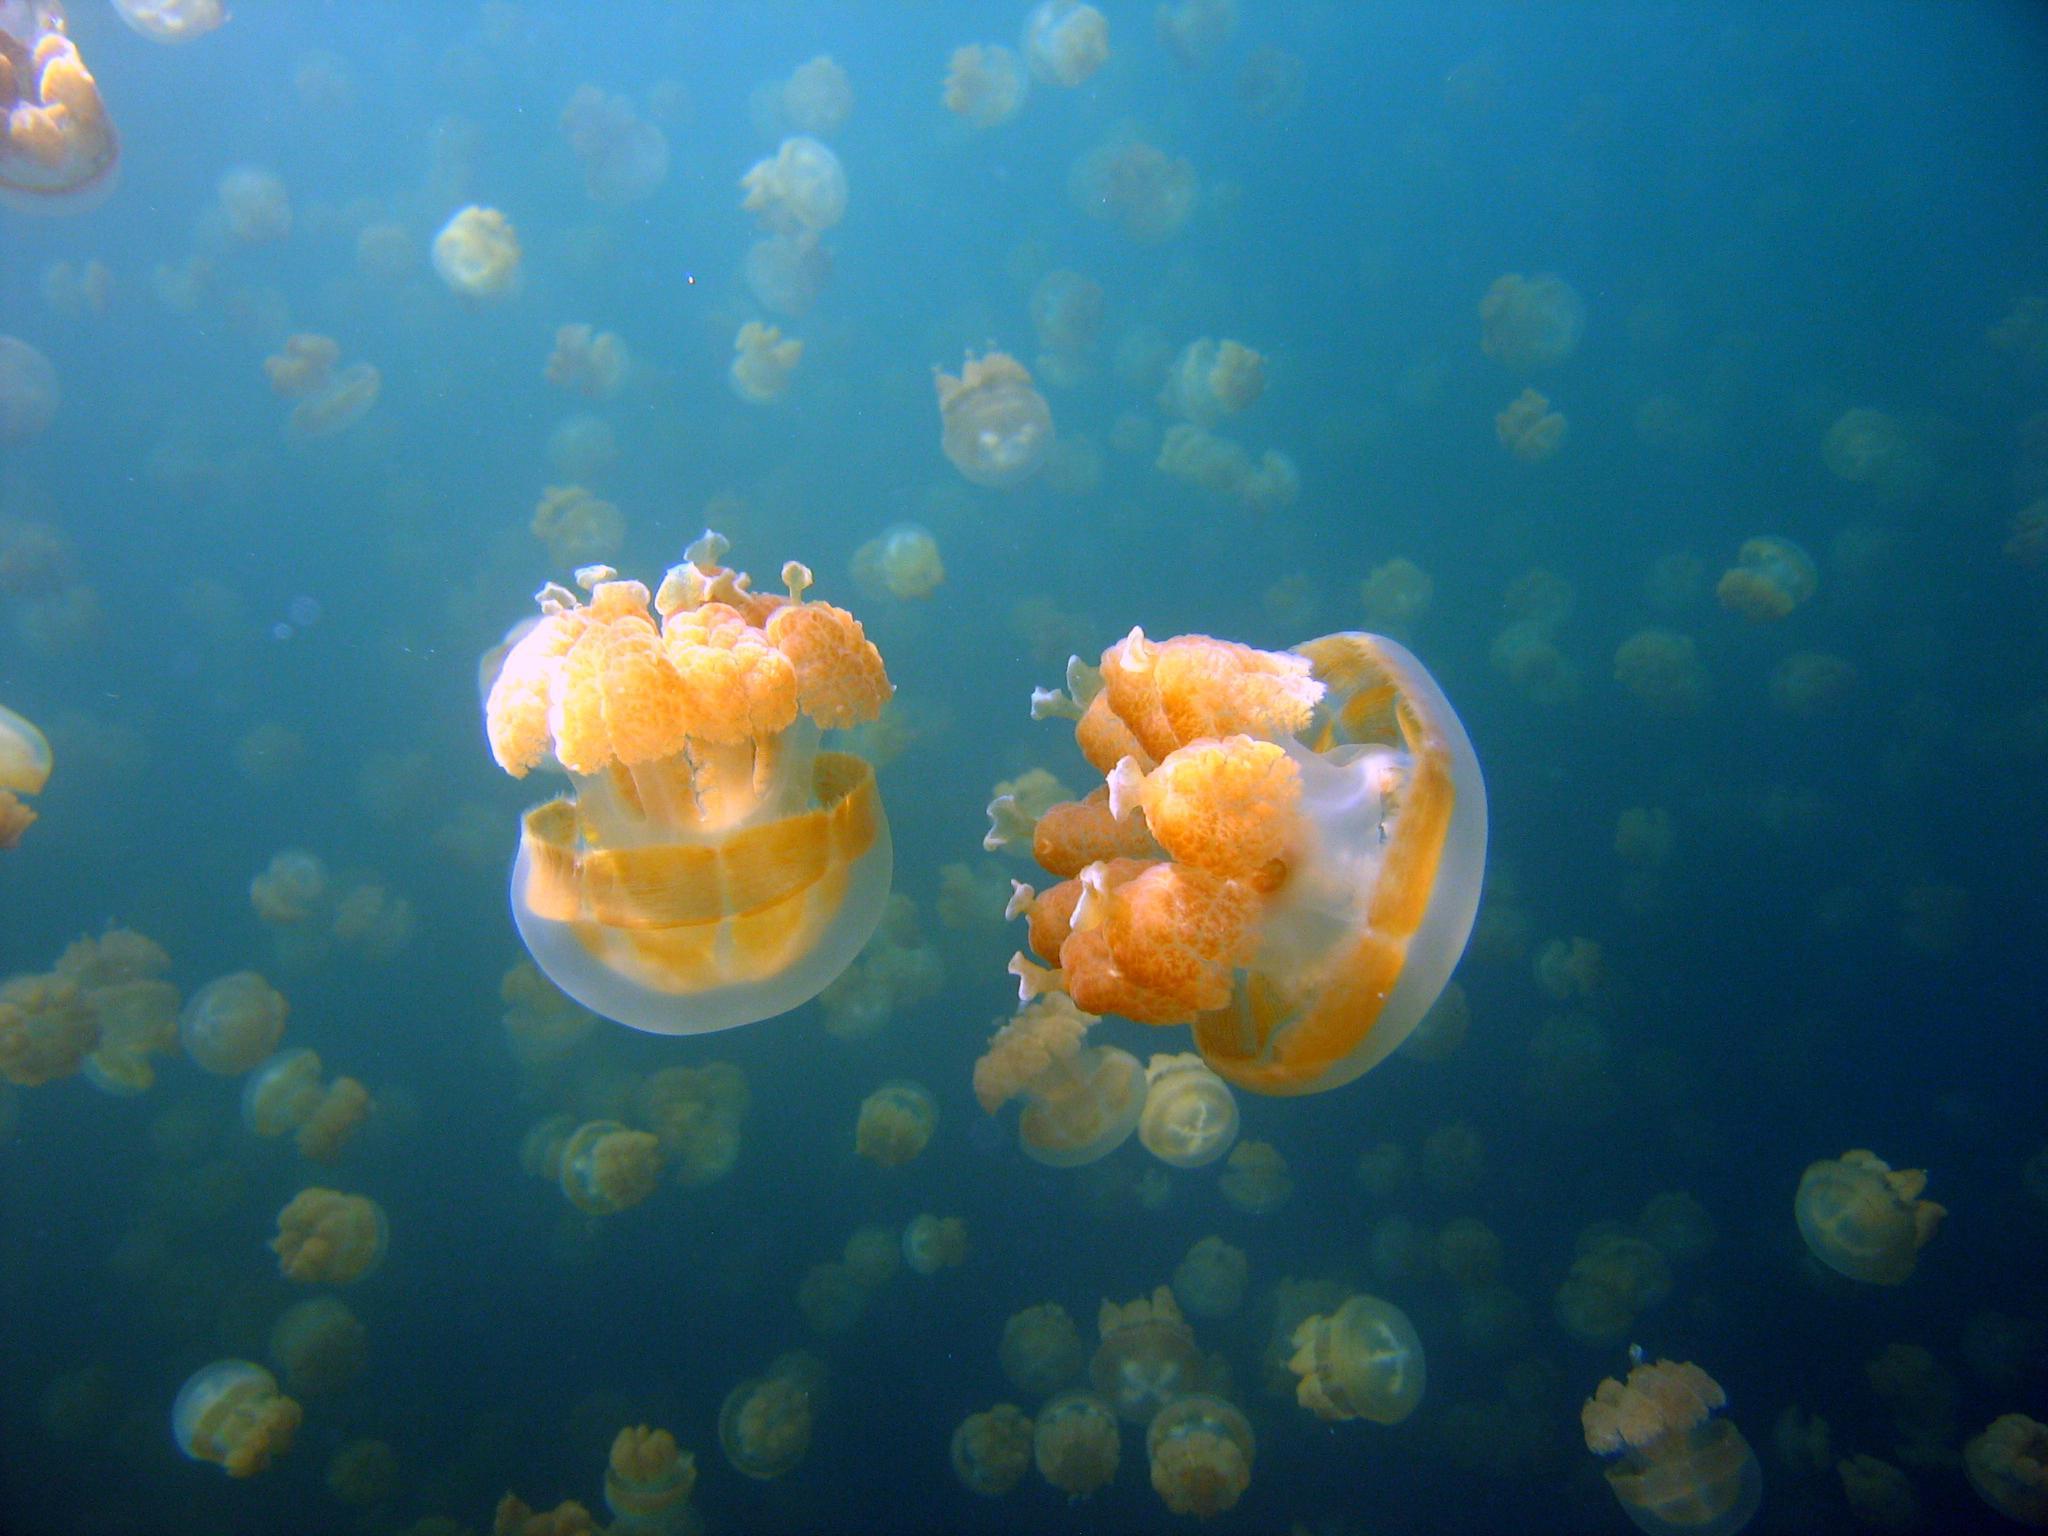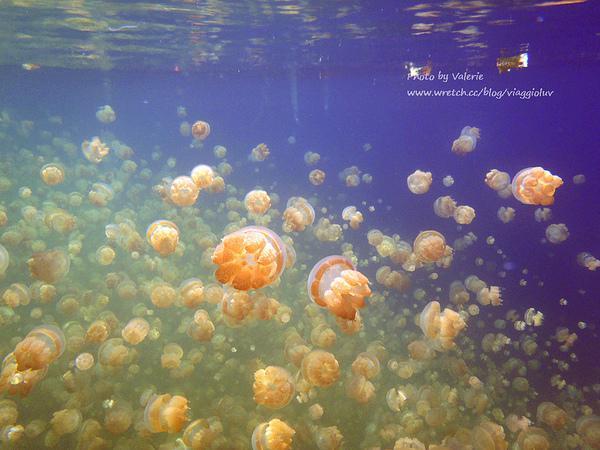The first image is the image on the left, the second image is the image on the right. Examine the images to the left and right. Is the description "A person is in one of the pictures." accurate? Answer yes or no. No. The first image is the image on the left, the second image is the image on the right. Evaluate the accuracy of this statement regarding the images: "An image shows a human present with jellyfish.". Is it true? Answer yes or no. No. 